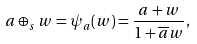<formula> <loc_0><loc_0><loc_500><loc_500>a \oplus _ { s } w = \psi _ { a } ( { w } ) = \frac { a + w } { 1 + \overline { a } w } ,</formula> 